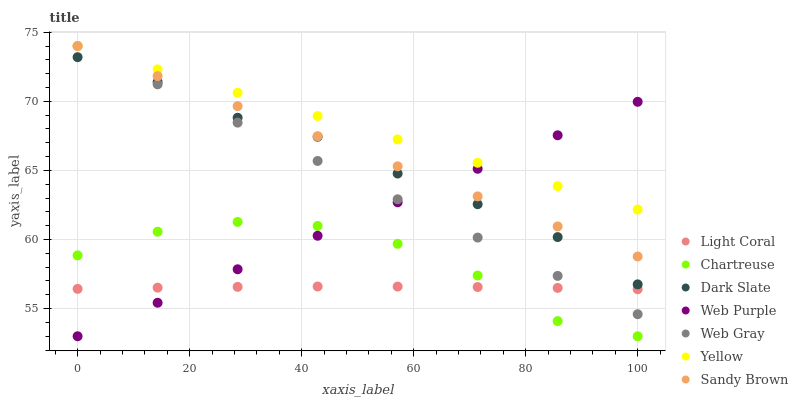Does Light Coral have the minimum area under the curve?
Answer yes or no. Yes. Does Yellow have the maximum area under the curve?
Answer yes or no. Yes. Does Web Purple have the minimum area under the curve?
Answer yes or no. No. Does Web Purple have the maximum area under the curve?
Answer yes or no. No. Is Web Purple the smoothest?
Answer yes or no. Yes. Is Chartreuse the roughest?
Answer yes or no. Yes. Is Yellow the smoothest?
Answer yes or no. No. Is Yellow the roughest?
Answer yes or no. No. Does Web Purple have the lowest value?
Answer yes or no. Yes. Does Yellow have the lowest value?
Answer yes or no. No. Does Sandy Brown have the highest value?
Answer yes or no. Yes. Does Web Purple have the highest value?
Answer yes or no. No. Is Chartreuse less than Yellow?
Answer yes or no. Yes. Is Web Gray greater than Chartreuse?
Answer yes or no. Yes. Does Dark Slate intersect Web Gray?
Answer yes or no. Yes. Is Dark Slate less than Web Gray?
Answer yes or no. No. Is Dark Slate greater than Web Gray?
Answer yes or no. No. Does Chartreuse intersect Yellow?
Answer yes or no. No. 